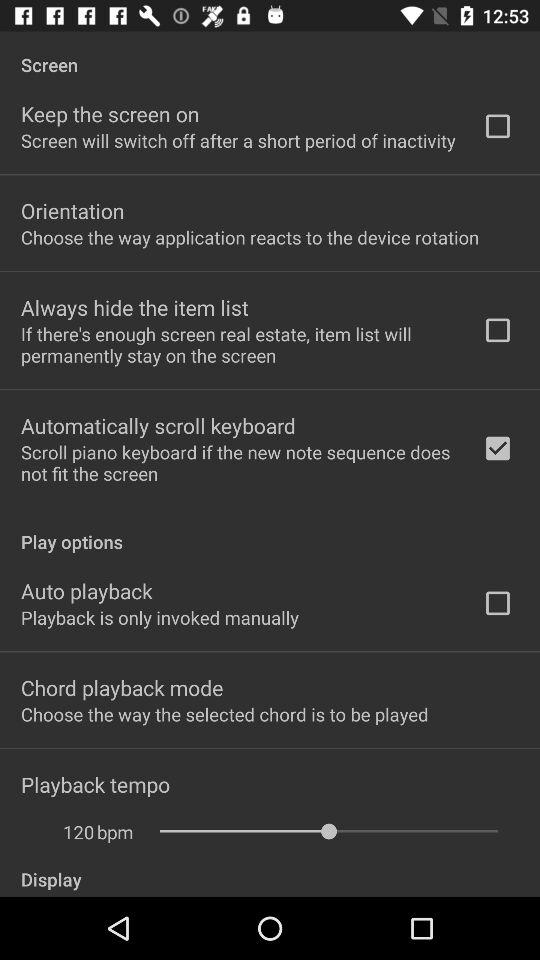What is the status of "Auto playback"? The status of "Auto playback" is "off". 